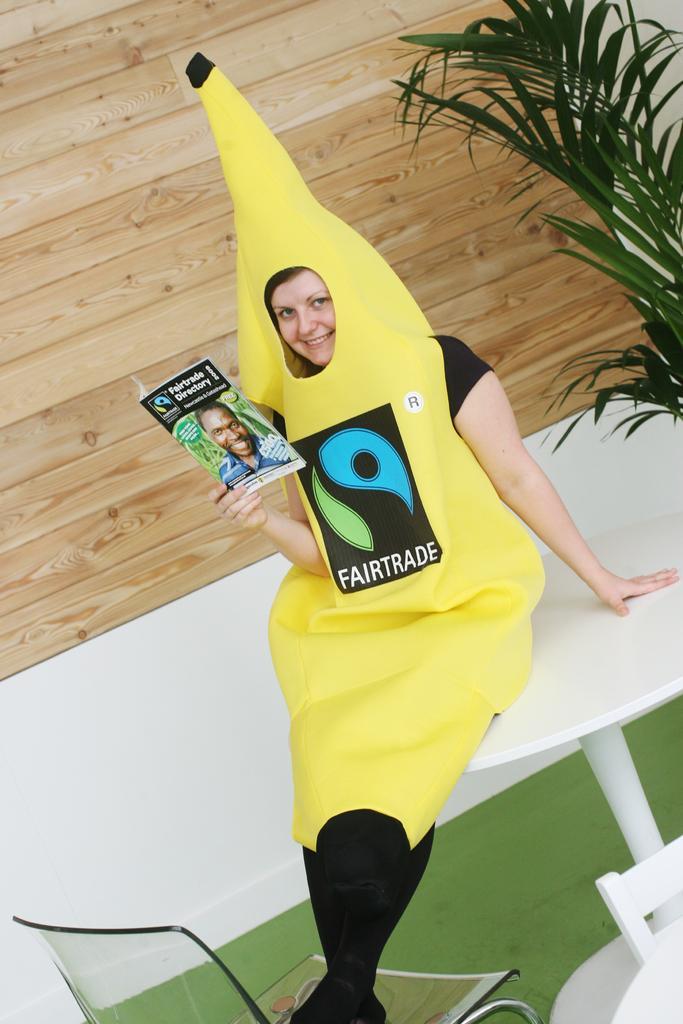Please provide a concise description of this image. In this picture we can see a woman sitting on a white table. She is holding a magazine. On the right side of the picture we can see a plant. At the bottom we can see a chair. 